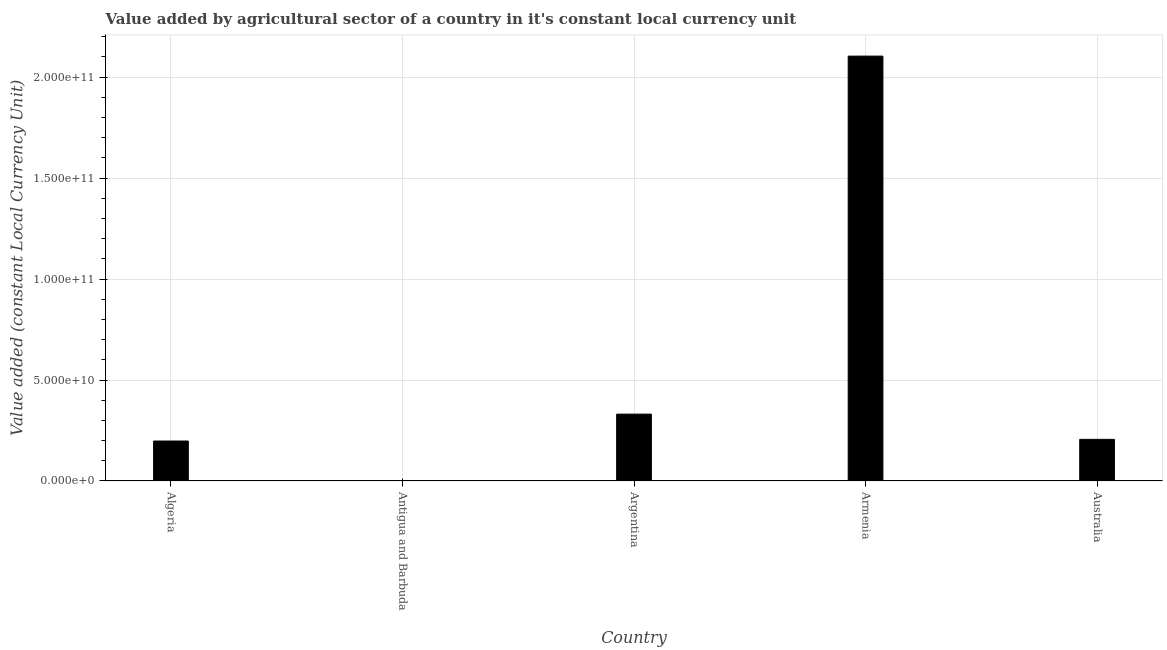Does the graph contain any zero values?
Make the answer very short. No. What is the title of the graph?
Offer a terse response. Value added by agricultural sector of a country in it's constant local currency unit. What is the label or title of the Y-axis?
Ensure brevity in your answer.  Value added (constant Local Currency Unit). What is the value added by agriculture sector in Antigua and Barbuda?
Keep it short and to the point. 4.43e+07. Across all countries, what is the maximum value added by agriculture sector?
Your response must be concise. 2.10e+11. Across all countries, what is the minimum value added by agriculture sector?
Ensure brevity in your answer.  4.43e+07. In which country was the value added by agriculture sector maximum?
Your response must be concise. Armenia. In which country was the value added by agriculture sector minimum?
Give a very brief answer. Antigua and Barbuda. What is the sum of the value added by agriculture sector?
Your answer should be very brief. 2.84e+11. What is the difference between the value added by agriculture sector in Algeria and Australia?
Keep it short and to the point. -8.23e+08. What is the average value added by agriculture sector per country?
Give a very brief answer. 5.68e+1. What is the median value added by agriculture sector?
Give a very brief answer. 2.06e+1. In how many countries, is the value added by agriculture sector greater than 50000000000 LCU?
Give a very brief answer. 1. What is the ratio of the value added by agriculture sector in Antigua and Barbuda to that in Armenia?
Provide a succinct answer. 0. What is the difference between the highest and the second highest value added by agriculture sector?
Offer a very short reply. 1.77e+11. What is the difference between the highest and the lowest value added by agriculture sector?
Provide a succinct answer. 2.10e+11. Are all the bars in the graph horizontal?
Keep it short and to the point. No. What is the difference between two consecutive major ticks on the Y-axis?
Ensure brevity in your answer.  5.00e+1. Are the values on the major ticks of Y-axis written in scientific E-notation?
Offer a very short reply. Yes. What is the Value added (constant Local Currency Unit) in Algeria?
Ensure brevity in your answer.  1.98e+1. What is the Value added (constant Local Currency Unit) of Antigua and Barbuda?
Your response must be concise. 4.43e+07. What is the Value added (constant Local Currency Unit) in Argentina?
Your response must be concise. 3.31e+1. What is the Value added (constant Local Currency Unit) in Armenia?
Offer a very short reply. 2.10e+11. What is the Value added (constant Local Currency Unit) of Australia?
Ensure brevity in your answer.  2.06e+1. What is the difference between the Value added (constant Local Currency Unit) in Algeria and Antigua and Barbuda?
Your response must be concise. 1.97e+1. What is the difference between the Value added (constant Local Currency Unit) in Algeria and Argentina?
Your response must be concise. -1.33e+1. What is the difference between the Value added (constant Local Currency Unit) in Algeria and Armenia?
Your answer should be very brief. -1.91e+11. What is the difference between the Value added (constant Local Currency Unit) in Algeria and Australia?
Ensure brevity in your answer.  -8.23e+08. What is the difference between the Value added (constant Local Currency Unit) in Antigua and Barbuda and Argentina?
Your answer should be very brief. -3.31e+1. What is the difference between the Value added (constant Local Currency Unit) in Antigua and Barbuda and Armenia?
Your response must be concise. -2.10e+11. What is the difference between the Value added (constant Local Currency Unit) in Antigua and Barbuda and Australia?
Ensure brevity in your answer.  -2.06e+1. What is the difference between the Value added (constant Local Currency Unit) in Argentina and Armenia?
Keep it short and to the point. -1.77e+11. What is the difference between the Value added (constant Local Currency Unit) in Argentina and Australia?
Provide a short and direct response. 1.25e+1. What is the difference between the Value added (constant Local Currency Unit) in Armenia and Australia?
Keep it short and to the point. 1.90e+11. What is the ratio of the Value added (constant Local Currency Unit) in Algeria to that in Antigua and Barbuda?
Provide a succinct answer. 446.54. What is the ratio of the Value added (constant Local Currency Unit) in Algeria to that in Argentina?
Your answer should be very brief. 0.6. What is the ratio of the Value added (constant Local Currency Unit) in Algeria to that in Armenia?
Offer a very short reply. 0.09. What is the ratio of the Value added (constant Local Currency Unit) in Antigua and Barbuda to that in Argentina?
Your answer should be compact. 0. What is the ratio of the Value added (constant Local Currency Unit) in Antigua and Barbuda to that in Australia?
Provide a short and direct response. 0. What is the ratio of the Value added (constant Local Currency Unit) in Argentina to that in Armenia?
Ensure brevity in your answer.  0.16. What is the ratio of the Value added (constant Local Currency Unit) in Argentina to that in Australia?
Your response must be concise. 1.61. What is the ratio of the Value added (constant Local Currency Unit) in Armenia to that in Australia?
Ensure brevity in your answer.  10.21. 